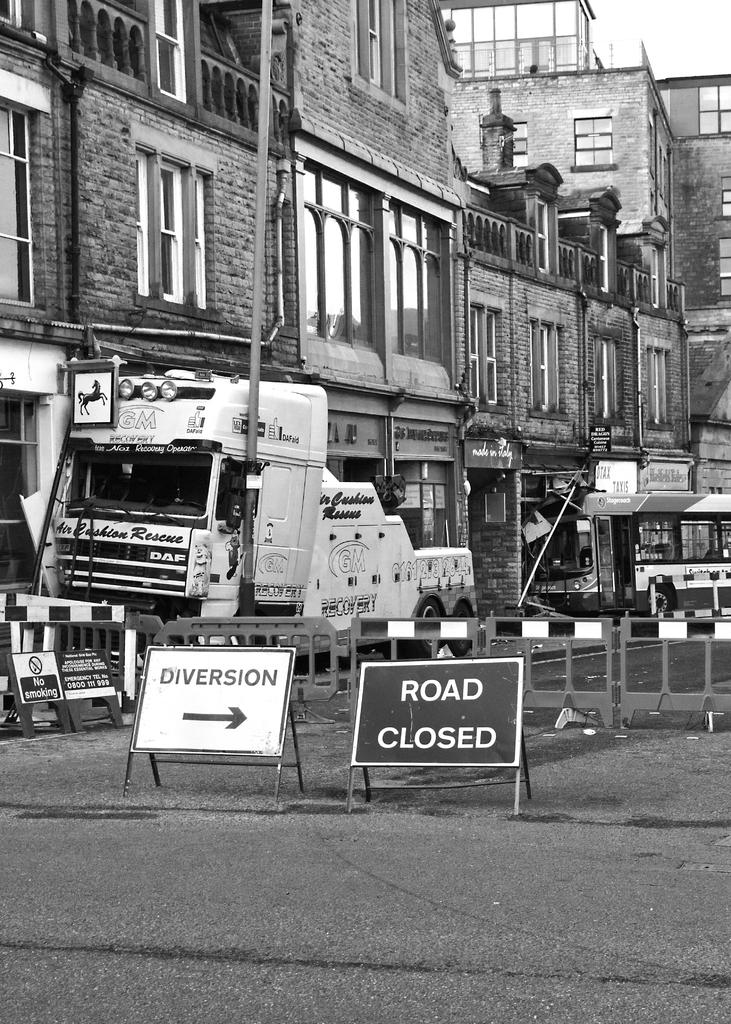What is the color scheme of the image? The image is black and white. What types of structures can be seen in the image? There are buildings in the image. What else is present in the image besides buildings? There are vehicles, boards with text, the ground, bar gates, a pole, and the sky visible in the image. What type of line is being produced by the unit in the image? There is no line or unit present in the image; it features a black and white scene with buildings, vehicles, boards with text, the ground, bar gates, a pole, and the sky. 